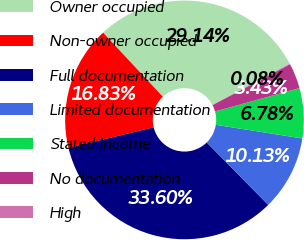Convert chart to OTSL. <chart><loc_0><loc_0><loc_500><loc_500><pie_chart><fcel>Owner occupied<fcel>Non-owner occupied<fcel>Full documentation<fcel>Limited documentation<fcel>Stated income<fcel>No documentation<fcel>High<nl><fcel>29.14%<fcel>16.83%<fcel>33.6%<fcel>10.13%<fcel>6.78%<fcel>3.43%<fcel>0.08%<nl></chart> 